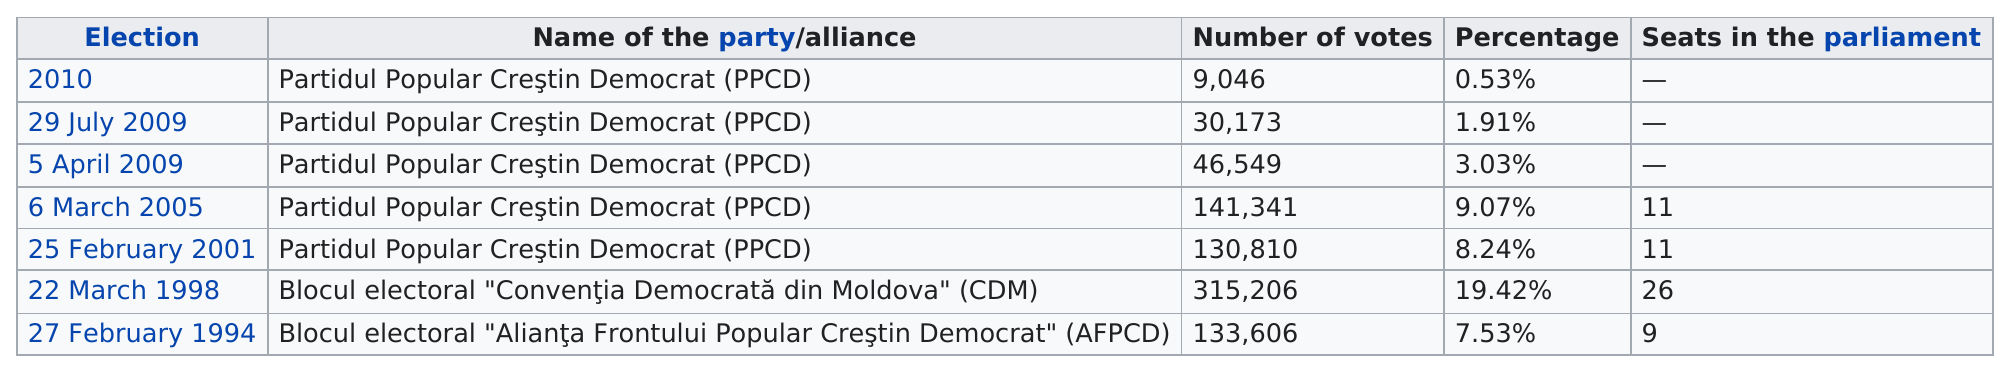Highlight a few significant elements in this photo. There have been a total of 7 elections. The Democratic Party of Moldova (CDM) received more than 300,000 votes in the parliamentary election. Partidul Popular Creştin Democrat (PPCD) has received the least number of votes in all elections from 1994 to 2010. The 2010 election had only 9,046 votes. The 2010 election did not have any seats in parliament. 